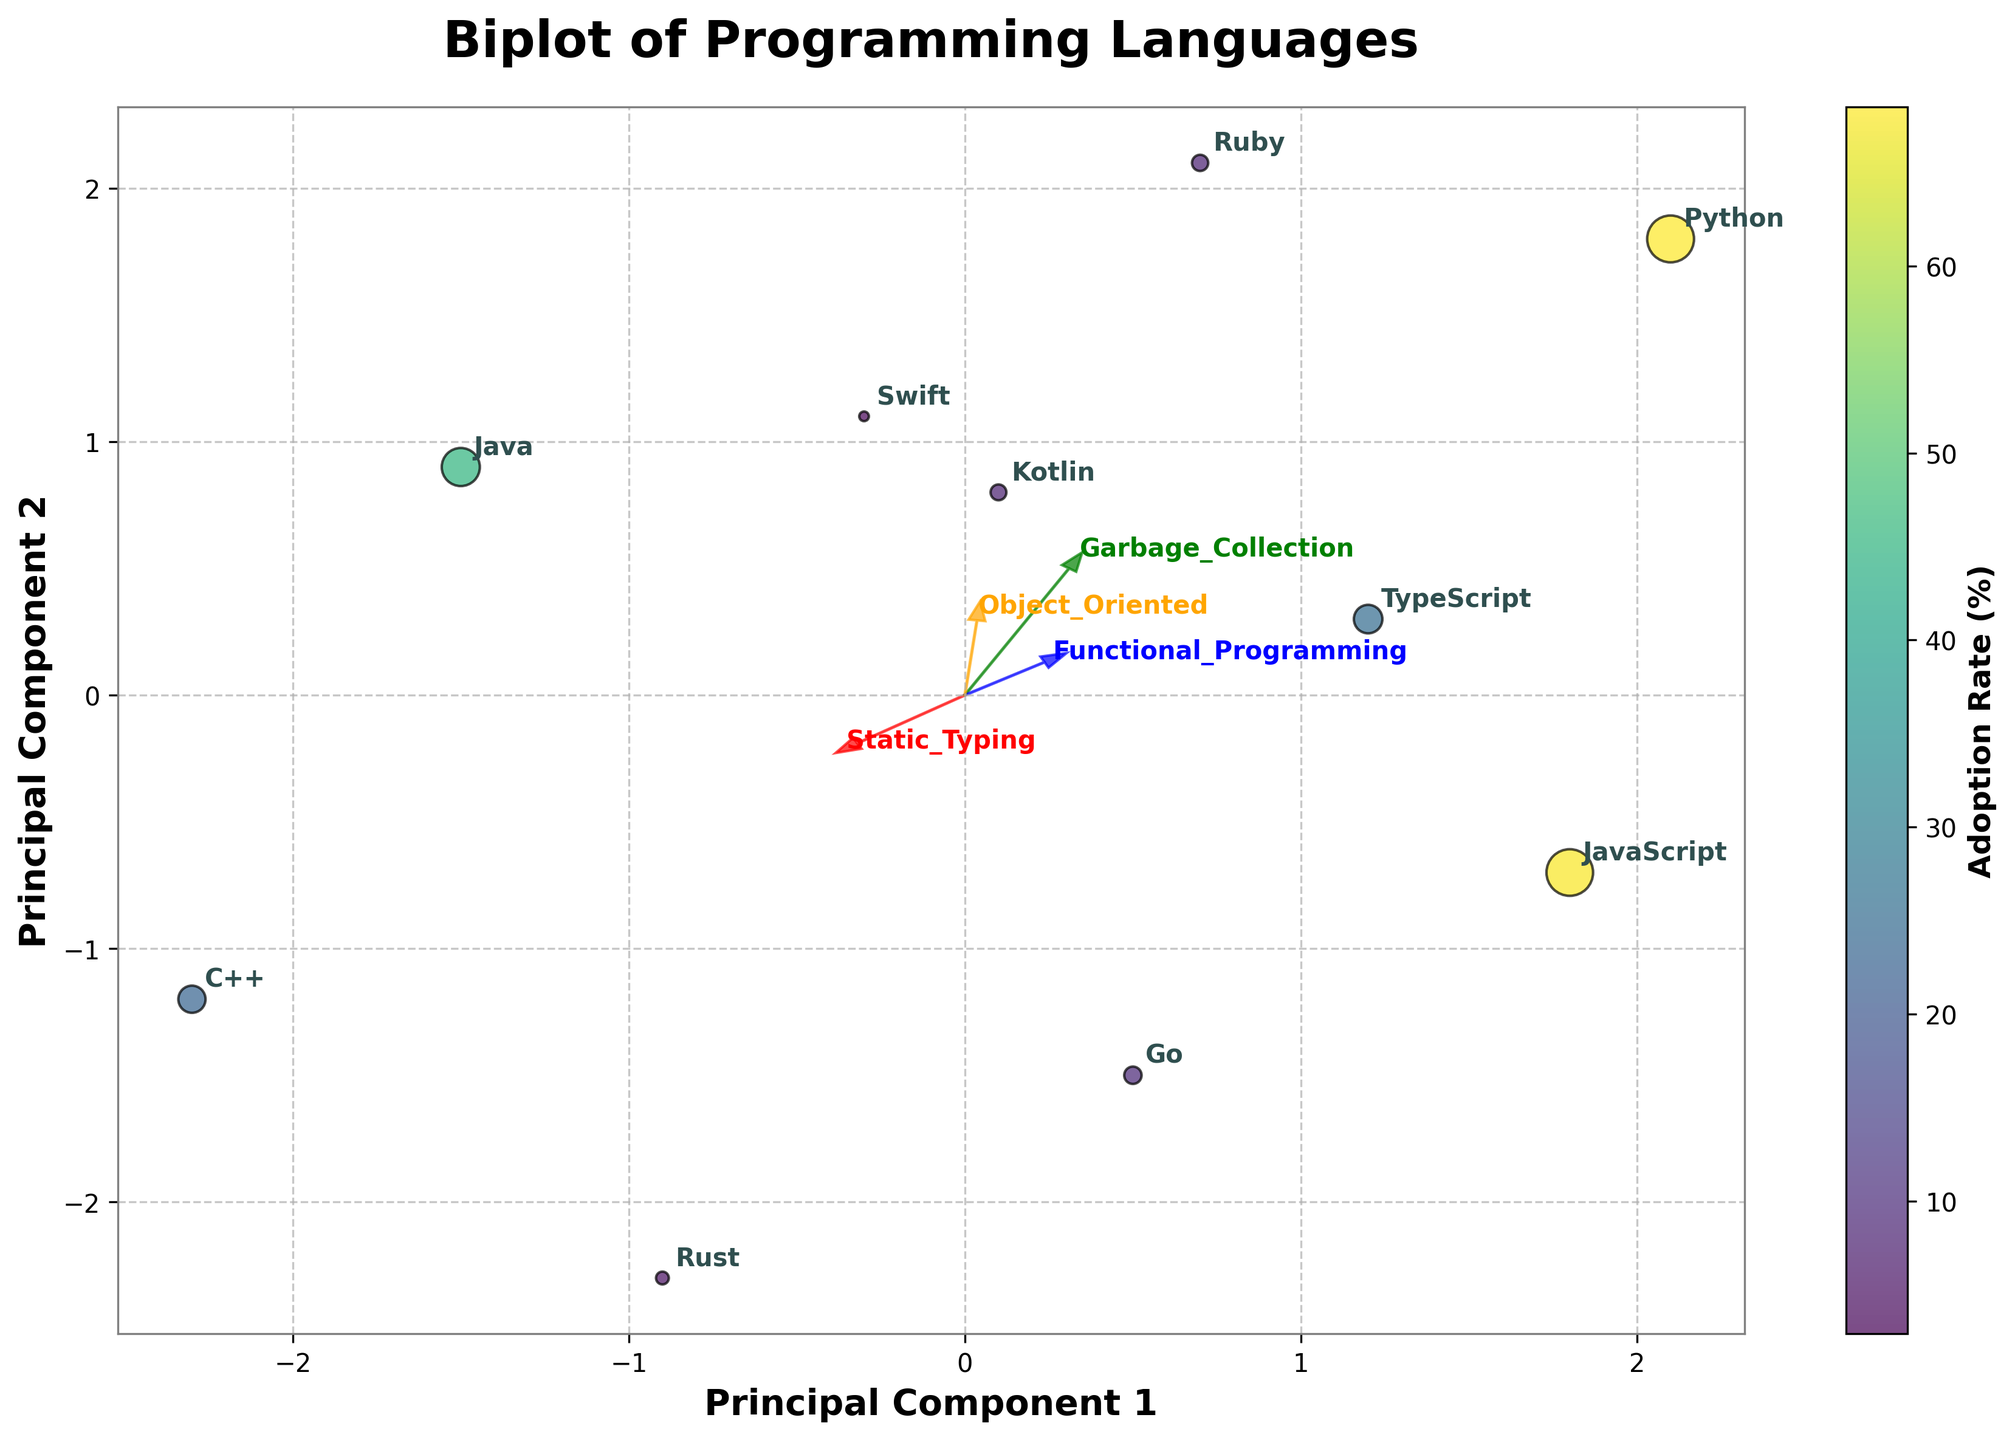what is the adoption rate of Java? Look at the position of Java in the scatter plot and read the value associated with its color density on the colorbar. Java is annotated with a specific adoption rate of 45.3%, corresponding to its color on the plot.
Answer: 45.3% Which language has the highest adoption rate on the plot? Identify the data point with the largest size and the highest value on the colorbar. Python shows the highest adoption rate at 68.5%.
Answer: Python Which principal component axis (PC1 or PC2) do most languages cluster around the zero value? Observe the dispersion of points around the vertical and horizontal axes. Most languages cluster around the zero value on PC2.
Answer: PC2 Which languages have static typing and where are they located on the plot? Look at the directions of the "Static Typing" arrow (static typing is indicated by language positions and arrow direction). Languages like Java, C++, Go, Rust, TypeScript, Swift, and Kotlin have static typing and are located towards the left and neutral zones of PC1.
Answer: Java, C++, Go, Rust, TypeScript, Swift, Kotlin What is the relationship between garbage collection and adoption rate in this plot? Examine the languages with garbage collection (represented by green arrow) and their relative positions and adoption rates. Languages with garbage collection like Python, Ruby, Go, Kotlin, and Swift generally have higher adoption rates, though there are exceptions.
Answer: General trend, higher adoption Which feature vector has the longest arrow and what is its color? Look at the length of the arrows corresponding to each feature vector and their associated colors. The arrow for "Object Oriented" is the longest and it is colored orange.
Answer: Object Oriented, orange How does Python compare to JavaScript in terms of PC1? Compare their horizontal positions on the PC1 axis. Python has a higher value on PC1 compared to JavaScript.
Answer: Python > JavaScript Where is the point for Rust, and what does its adoption rate and feature preference suggest? Locate Rust's position in the lower right quadrant (negative sides of both PC1 and PC2) and read its adoption rate of 5.1% from the color and size of the point. Rust’s preference towards static typing and functional programming is evident.
Answer: Lower right quadrant; 5.1%; static typing and functional programming Which languages align closely with the "Functional Programming" vector, and what could this imply about their programming paradigms? Look at the blue arrow and identify the data points near its direction. Languages such as Python, JavaScript, Ruby, and Rust are closely aligned with the functional programming vector, indicating they support or emphasize functional programming paradigms.
Answer: Python, JavaScript, Ruby, Rust; functional programming If the functional programming vector is focused on, which principal component seems most correlated with it? Observe the feature vector direction and its projection. The functional programming vector aligns mainly with positive PC1 and slightly positive PC2 axes.
Answer: PC1 